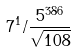<formula> <loc_0><loc_0><loc_500><loc_500>7 ^ { 1 } / \frac { 5 ^ { 3 8 6 } } { \sqrt { 1 0 8 } }</formula> 